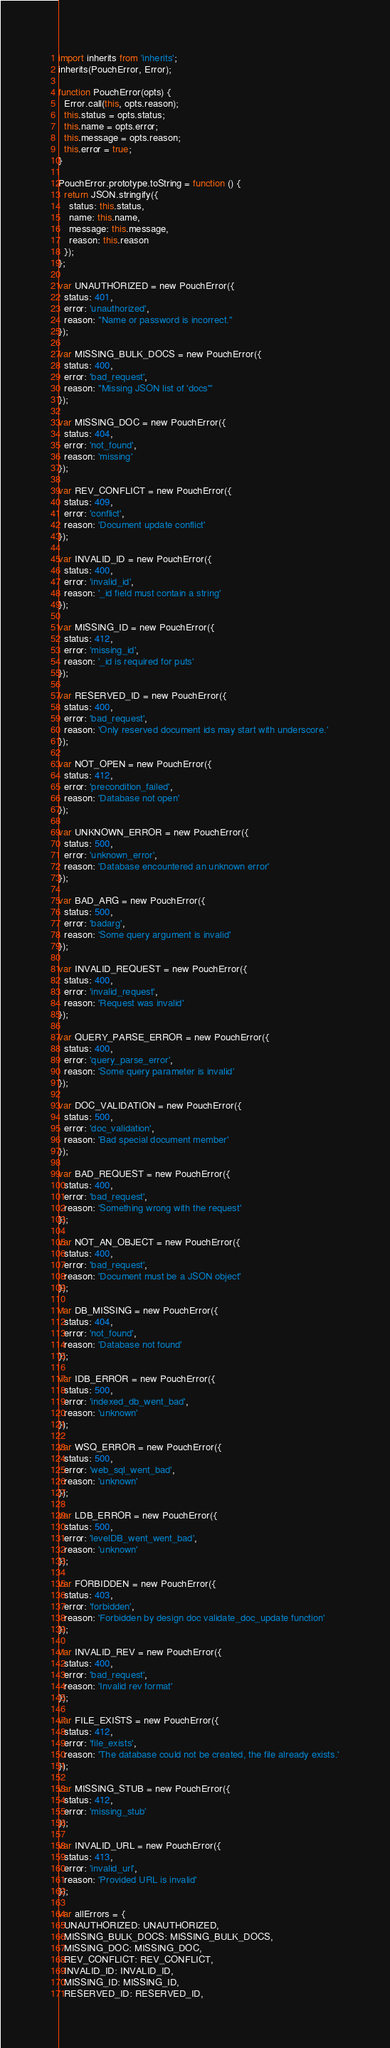<code> <loc_0><loc_0><loc_500><loc_500><_JavaScript_>import inherits from 'inherits';
inherits(PouchError, Error);

function PouchError(opts) {
  Error.call(this, opts.reason);
  this.status = opts.status;
  this.name = opts.error;
  this.message = opts.reason;
  this.error = true;
}

PouchError.prototype.toString = function () {
  return JSON.stringify({
    status: this.status,
    name: this.name,
    message: this.message,
    reason: this.reason
  });
};

var UNAUTHORIZED = new PouchError({
  status: 401,
  error: 'unauthorized',
  reason: "Name or password is incorrect."
});

var MISSING_BULK_DOCS = new PouchError({
  status: 400,
  error: 'bad_request',
  reason: "Missing JSON list of 'docs'"
});

var MISSING_DOC = new PouchError({
  status: 404,
  error: 'not_found',
  reason: 'missing'
});

var REV_CONFLICT = new PouchError({
  status: 409,
  error: 'conflict',
  reason: 'Document update conflict'
});

var INVALID_ID = new PouchError({
  status: 400,
  error: 'invalid_id',
  reason: '_id field must contain a string'
});

var MISSING_ID = new PouchError({
  status: 412,
  error: 'missing_id',
  reason: '_id is required for puts'
});

var RESERVED_ID = new PouchError({
  status: 400,
  error: 'bad_request',
  reason: 'Only reserved document ids may start with underscore.'
});

var NOT_OPEN = new PouchError({
  status: 412,
  error: 'precondition_failed',
  reason: 'Database not open'
});

var UNKNOWN_ERROR = new PouchError({
  status: 500,
  error: 'unknown_error',
  reason: 'Database encountered an unknown error'
});

var BAD_ARG = new PouchError({
  status: 500,
  error: 'badarg',
  reason: 'Some query argument is invalid'
});

var INVALID_REQUEST = new PouchError({
  status: 400,
  error: 'invalid_request',
  reason: 'Request was invalid'
});

var QUERY_PARSE_ERROR = new PouchError({
  status: 400,
  error: 'query_parse_error',
  reason: 'Some query parameter is invalid'
});

var DOC_VALIDATION = new PouchError({
  status: 500,
  error: 'doc_validation',
  reason: 'Bad special document member'
});

var BAD_REQUEST = new PouchError({
  status: 400,
  error: 'bad_request',
  reason: 'Something wrong with the request'
});

var NOT_AN_OBJECT = new PouchError({
  status: 400,
  error: 'bad_request',
  reason: 'Document must be a JSON object'
});

var DB_MISSING = new PouchError({
  status: 404,
  error: 'not_found',
  reason: 'Database not found'
});

var IDB_ERROR = new PouchError({
  status: 500,
  error: 'indexed_db_went_bad',
  reason: 'unknown'
});

var WSQ_ERROR = new PouchError({
  status: 500,
  error: 'web_sql_went_bad',
  reason: 'unknown'
});

var LDB_ERROR = new PouchError({
  status: 500,
  error: 'levelDB_went_went_bad',
  reason: 'unknown'
});

var FORBIDDEN = new PouchError({
  status: 403,
  error: 'forbidden',
  reason: 'Forbidden by design doc validate_doc_update function'
});

var INVALID_REV = new PouchError({
  status: 400,
  error: 'bad_request',
  reason: 'Invalid rev format'
});

var FILE_EXISTS = new PouchError({
  status: 412,
  error: 'file_exists',
  reason: 'The database could not be created, the file already exists.'
});

var MISSING_STUB = new PouchError({
  status: 412,
  error: 'missing_stub'
});

var INVALID_URL = new PouchError({
  status: 413,
  error: 'invalid_url',
  reason: 'Provided URL is invalid'
});

var allErrors = {
  UNAUTHORIZED: UNAUTHORIZED,
  MISSING_BULK_DOCS: MISSING_BULK_DOCS,
  MISSING_DOC: MISSING_DOC,
  REV_CONFLICT: REV_CONFLICT,
  INVALID_ID: INVALID_ID,
  MISSING_ID: MISSING_ID,
  RESERVED_ID: RESERVED_ID,</code> 